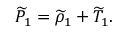<formula> <loc_0><loc_0><loc_500><loc_500>\widetilde { P } _ { 1 } = \widetilde { \rho } _ { 1 } + \widetilde { T } _ { 1 } .</formula> 